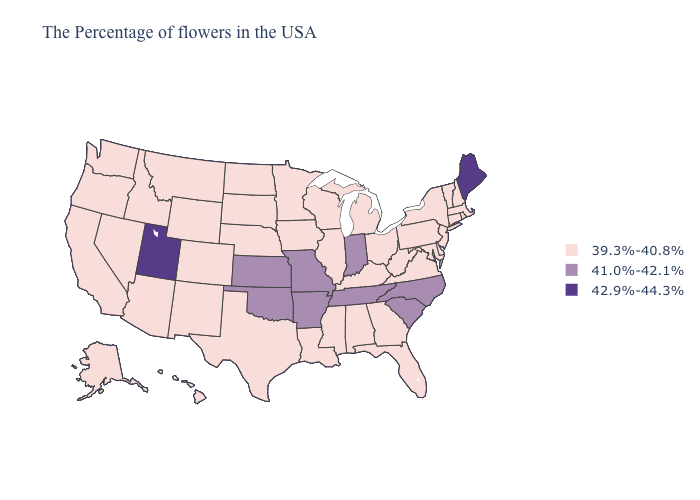What is the highest value in states that border Wyoming?
Answer briefly. 42.9%-44.3%. Which states have the lowest value in the USA?
Write a very short answer. Massachusetts, Rhode Island, New Hampshire, Vermont, Connecticut, New York, New Jersey, Delaware, Maryland, Pennsylvania, Virginia, West Virginia, Ohio, Florida, Georgia, Michigan, Kentucky, Alabama, Wisconsin, Illinois, Mississippi, Louisiana, Minnesota, Iowa, Nebraska, Texas, South Dakota, North Dakota, Wyoming, Colorado, New Mexico, Montana, Arizona, Idaho, Nevada, California, Washington, Oregon, Alaska, Hawaii. What is the value of Iowa?
Answer briefly. 39.3%-40.8%. Among the states that border Kentucky , does Ohio have the highest value?
Give a very brief answer. No. Does the first symbol in the legend represent the smallest category?
Give a very brief answer. Yes. Name the states that have a value in the range 41.0%-42.1%?
Quick response, please. North Carolina, South Carolina, Indiana, Tennessee, Missouri, Arkansas, Kansas, Oklahoma. Name the states that have a value in the range 39.3%-40.8%?
Write a very short answer. Massachusetts, Rhode Island, New Hampshire, Vermont, Connecticut, New York, New Jersey, Delaware, Maryland, Pennsylvania, Virginia, West Virginia, Ohio, Florida, Georgia, Michigan, Kentucky, Alabama, Wisconsin, Illinois, Mississippi, Louisiana, Minnesota, Iowa, Nebraska, Texas, South Dakota, North Dakota, Wyoming, Colorado, New Mexico, Montana, Arizona, Idaho, Nevada, California, Washington, Oregon, Alaska, Hawaii. Does West Virginia have the lowest value in the USA?
Short answer required. Yes. Name the states that have a value in the range 41.0%-42.1%?
Give a very brief answer. North Carolina, South Carolina, Indiana, Tennessee, Missouri, Arkansas, Kansas, Oklahoma. Does Maine have the highest value in the USA?
Quick response, please. Yes. What is the value of Minnesota?
Answer briefly. 39.3%-40.8%. What is the highest value in the South ?
Give a very brief answer. 41.0%-42.1%. Name the states that have a value in the range 41.0%-42.1%?
Concise answer only. North Carolina, South Carolina, Indiana, Tennessee, Missouri, Arkansas, Kansas, Oklahoma. 